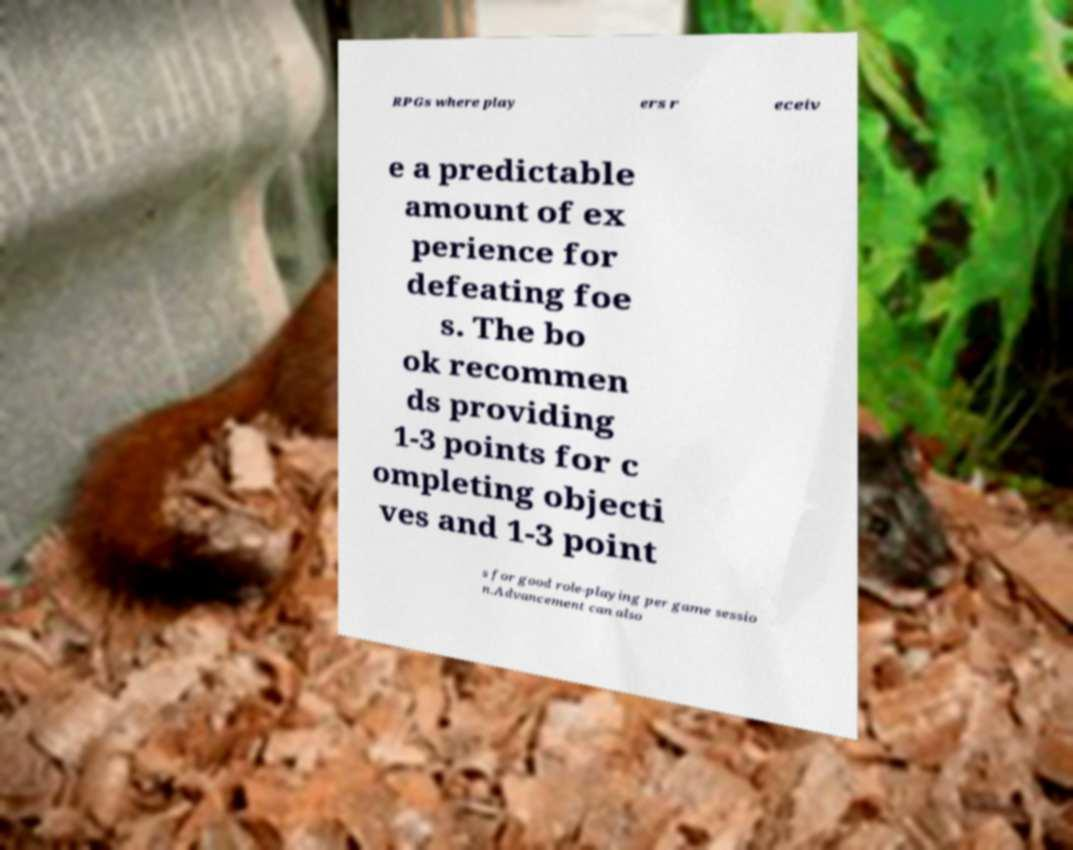Could you assist in decoding the text presented in this image and type it out clearly? RPGs where play ers r eceiv e a predictable amount of ex perience for defeating foe s. The bo ok recommen ds providing 1-3 points for c ompleting objecti ves and 1-3 point s for good role-playing per game sessio n.Advancement can also 